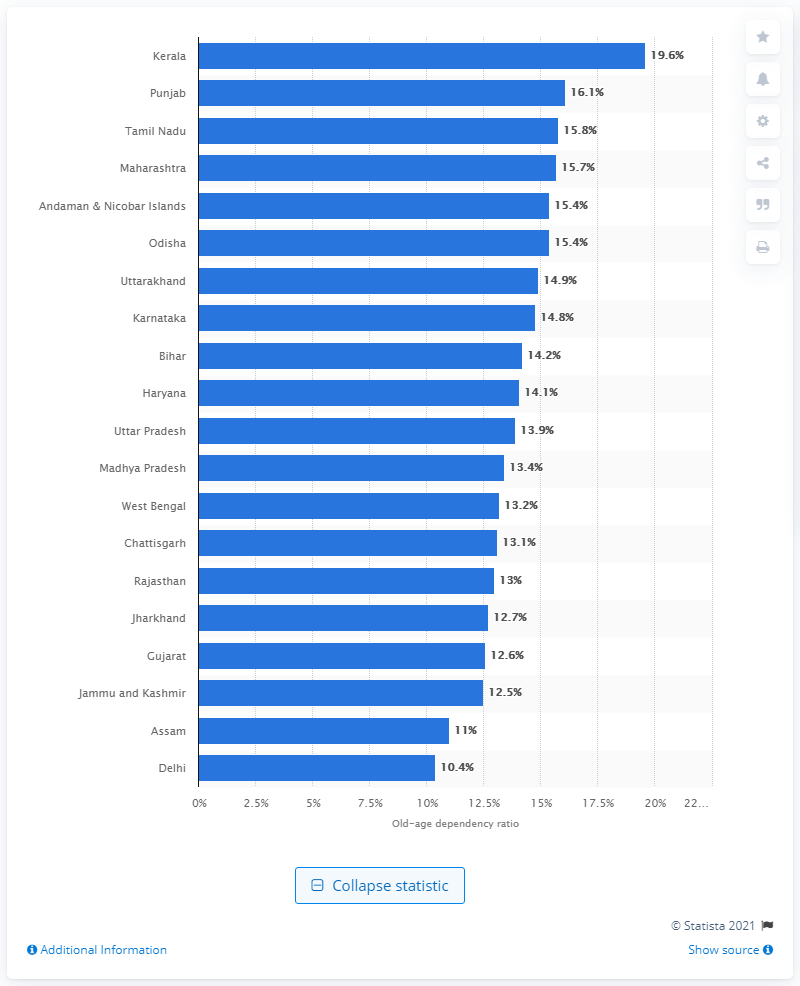Point out several critical features in this image. Punjab's old-age dependency ratio in 2011 was 16.1, which refers to the proportion of the population that is over the age of 60 and is dependent on others for their livelihood. 